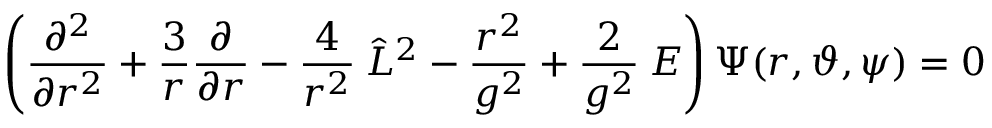<formula> <loc_0><loc_0><loc_500><loc_500>\left ( \frac { \partial ^ { 2 } } { \partial r ^ { 2 } } + \frac { 3 } { r } \frac { \partial } { \partial r } - \frac { 4 } { r ^ { 2 } } \, \hat { L } ^ { 2 } - \frac { r ^ { 2 } } { g ^ { 2 } } + \frac { 2 } { g ^ { 2 } } \, E \right ) \Psi ( r , \vartheta , \psi ) = 0</formula> 